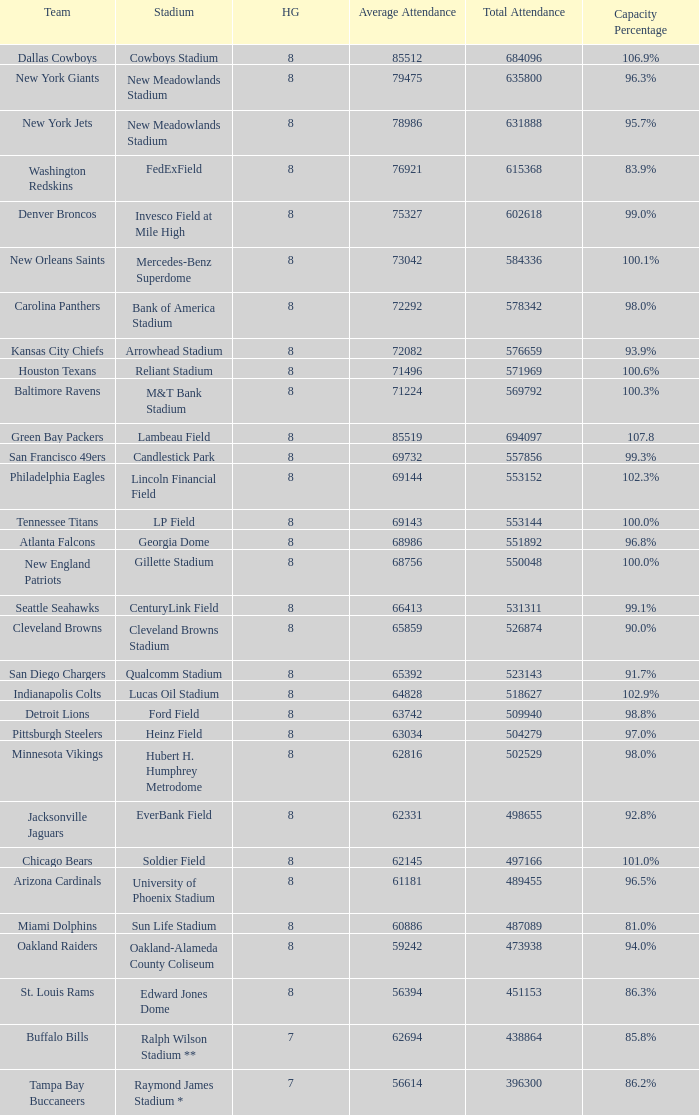How many home games are listed when the average attendance is 79475? 1.0. 